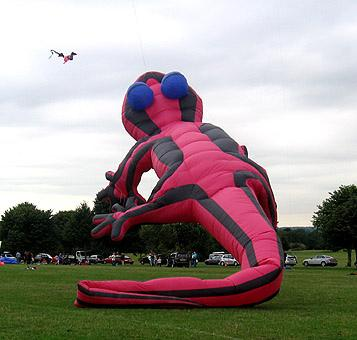What reptile is depicted in the extra large kite? Please explain your reasoning. chameleon. The reptile has lizard like features and bulbous eyes. 